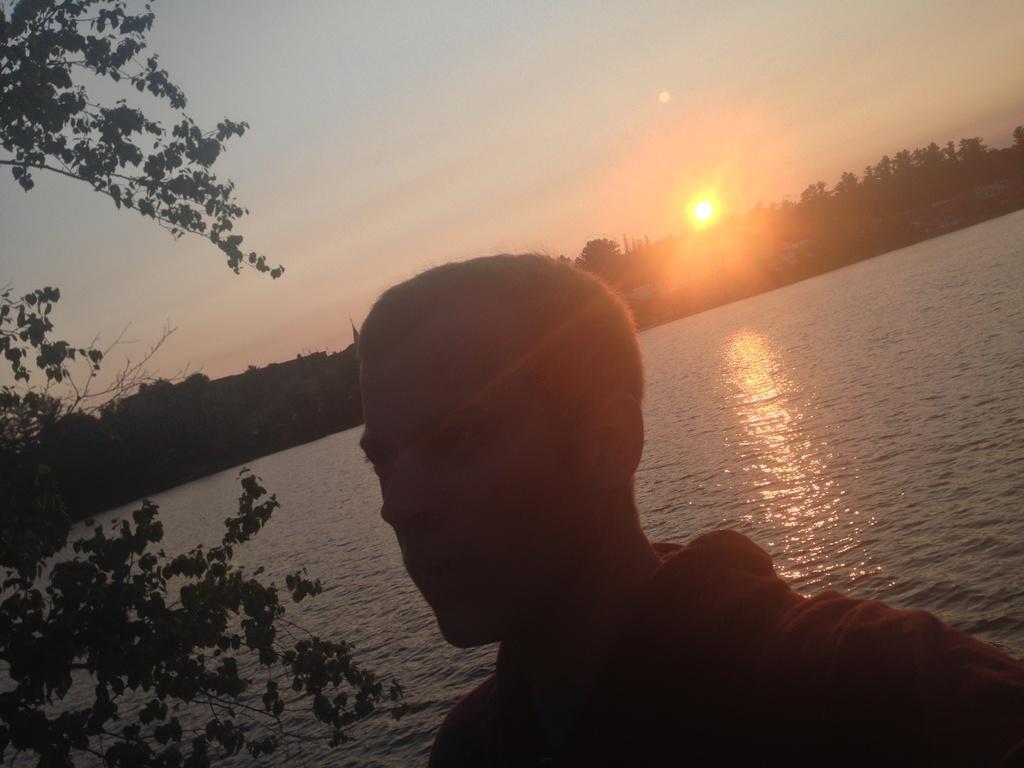How would you summarize this image in a sentence or two? In the image in the foreground there is one person and in the background there are trees buildings, and there is a river in the center and on the left side there is tree. At the top there is sky and sun. 